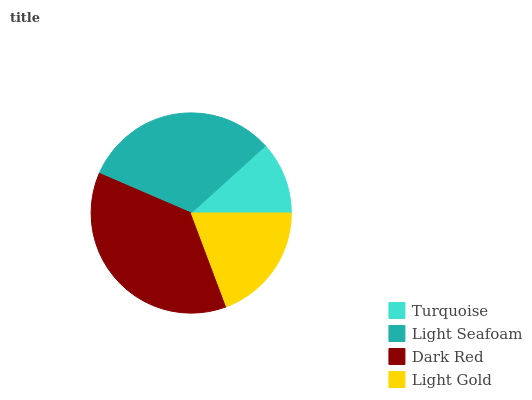Is Turquoise the minimum?
Answer yes or no. Yes. Is Dark Red the maximum?
Answer yes or no. Yes. Is Light Seafoam the minimum?
Answer yes or no. No. Is Light Seafoam the maximum?
Answer yes or no. No. Is Light Seafoam greater than Turquoise?
Answer yes or no. Yes. Is Turquoise less than Light Seafoam?
Answer yes or no. Yes. Is Turquoise greater than Light Seafoam?
Answer yes or no. No. Is Light Seafoam less than Turquoise?
Answer yes or no. No. Is Light Seafoam the high median?
Answer yes or no. Yes. Is Light Gold the low median?
Answer yes or no. Yes. Is Turquoise the high median?
Answer yes or no. No. Is Light Seafoam the low median?
Answer yes or no. No. 